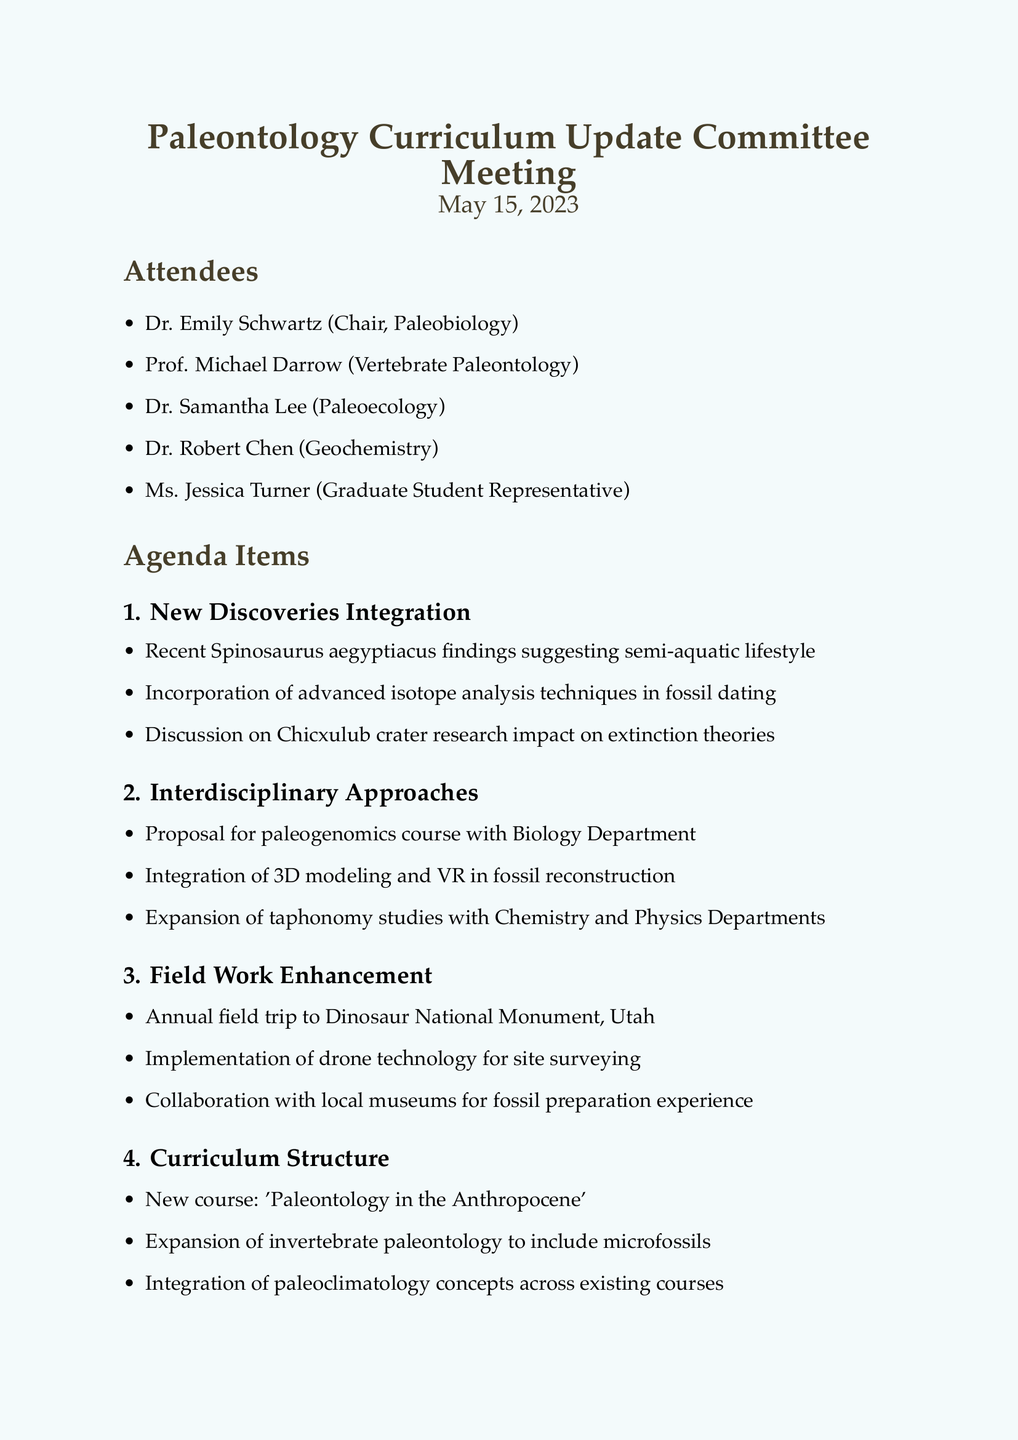what is the date of the meeting? The date of the meeting is listed at the beginning of the document.
Answer: May 15, 2023 who is the chair of the committee? The chair is identified in the list of attendees.
Answer: Dr. Emily Schwartz what is one of the proposed new courses? The proposed new courses are listed in the Curriculum Structure section.
Answer: Paleontology in the Anthropocene which paleontological finding is discussed regarding Spinosaurus? This finding is noted under the New Discoveries Integration agenda item.
Answer: Semi-aquatic lifestyle how many action items are listed? The action items are detailed towards the end of the document.
Answer: Four what collaborative course is proposed with the Biology Department? This proposal is included in the Interdisciplinary Approaches section.
Answer: Paleogenomics course who is responsible for drafting the paleogenomics course proposal? The action items specify who is responsible for each task.
Answer: Dr. Schwartz what technology is proposed for site surveying? This technology is mentioned under the Field Work Enhancement section.
Answer: Drone technology what request was made regarding laboratory sessions? The request is included in the Student Feedback section.
Answer: More hands-on laboratory sessions 